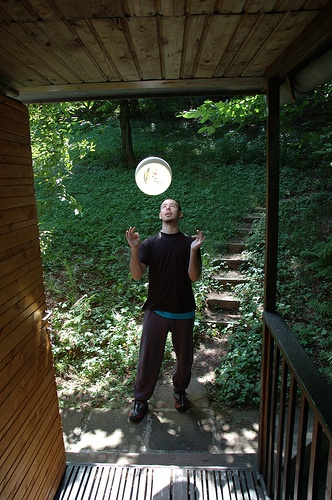Describe the objects in this image and their specific colors. I can see people in black, gray, and maroon tones and frisbee in black, white, darkgray, beige, and gray tones in this image. 